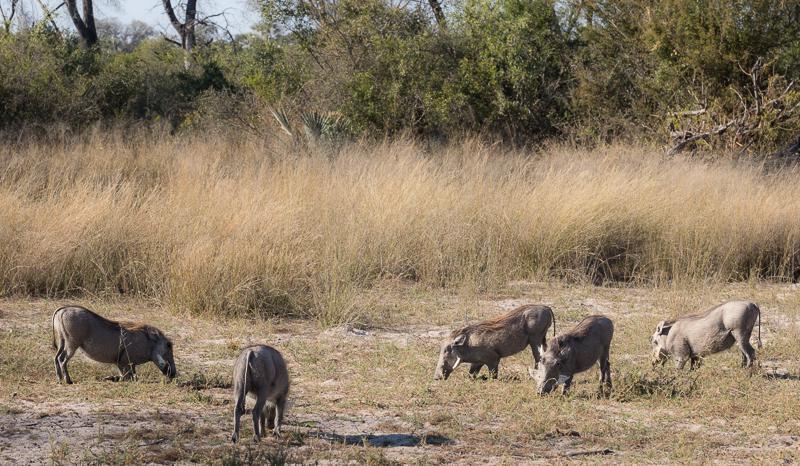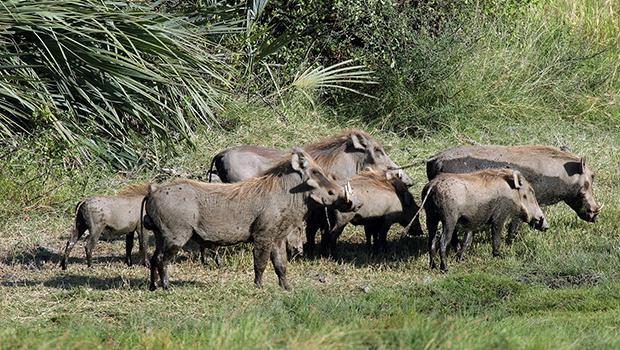The first image is the image on the left, the second image is the image on the right. Considering the images on both sides, is "Some of the animals are near a watery area." valid? Answer yes or no. No. The first image is the image on the left, the second image is the image on the right. Assess this claim about the two images: "An image includes at least five zebra standing on grass behind a patch of dirt.". Correct or not? Answer yes or no. No. 